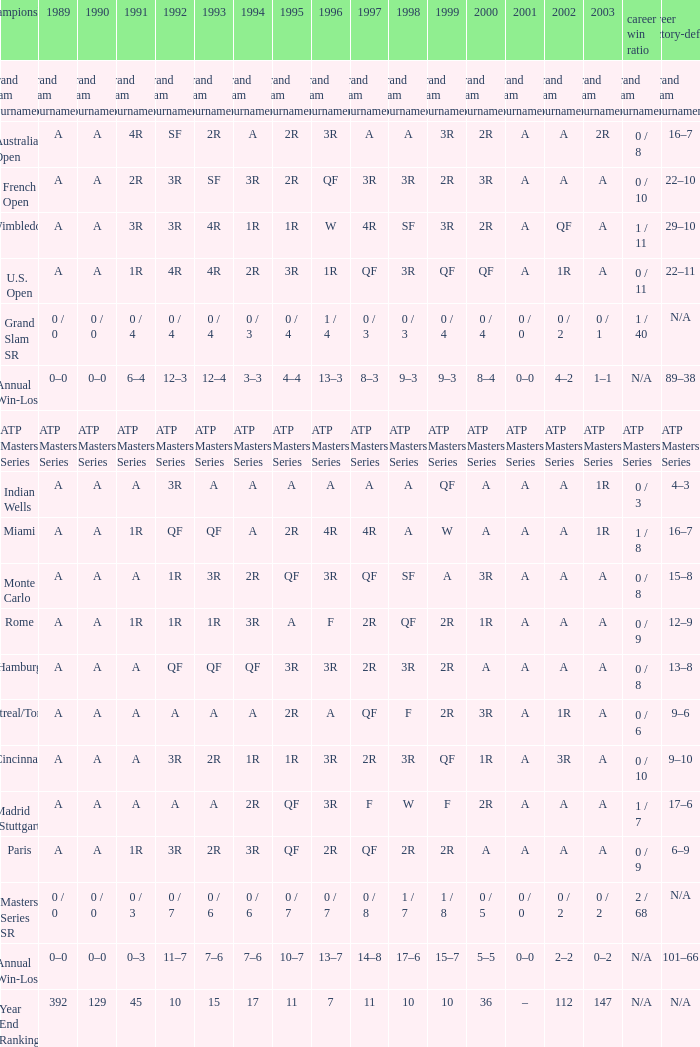What was the career SR with a value of A in 1980 and F in 1997? 1 / 7. 